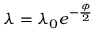Convert formula to latex. <formula><loc_0><loc_0><loc_500><loc_500>\lambda = \lambda _ { 0 } e ^ { - \frac { \phi } { 2 } }</formula> 